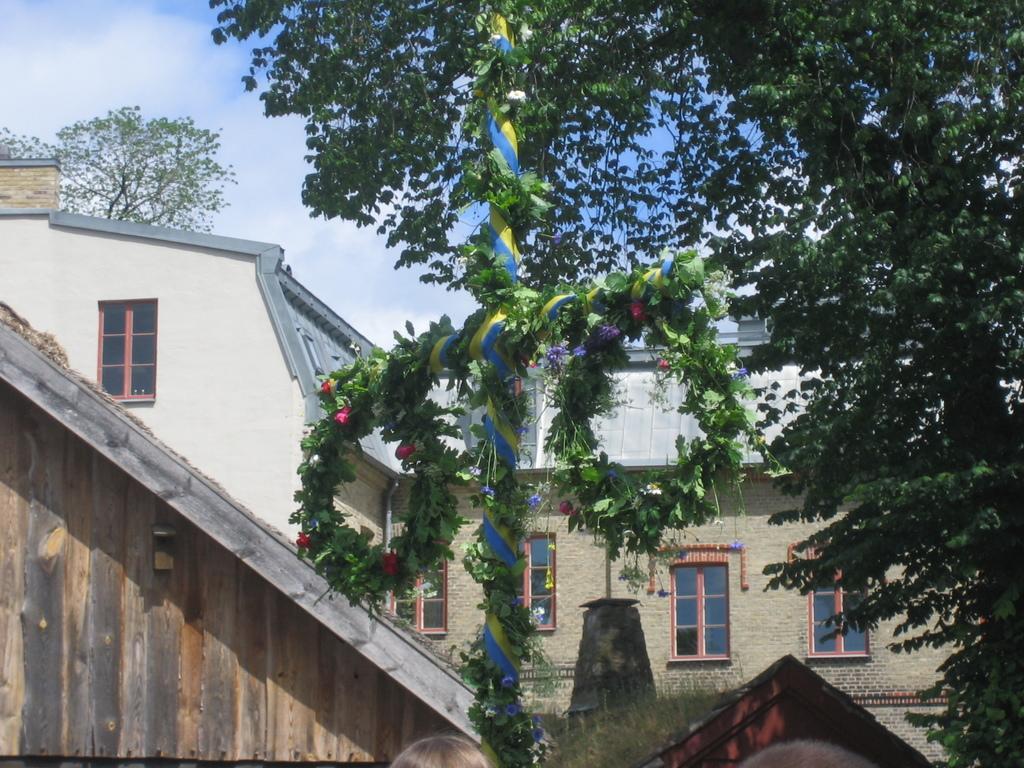In one or two sentences, can you explain what this image depicts? In this picture we can see a house, on the right side there is a tree, in the background we can see another tree, there is the sky at the top of the picture, we can see a pole and flowers in the middle. 